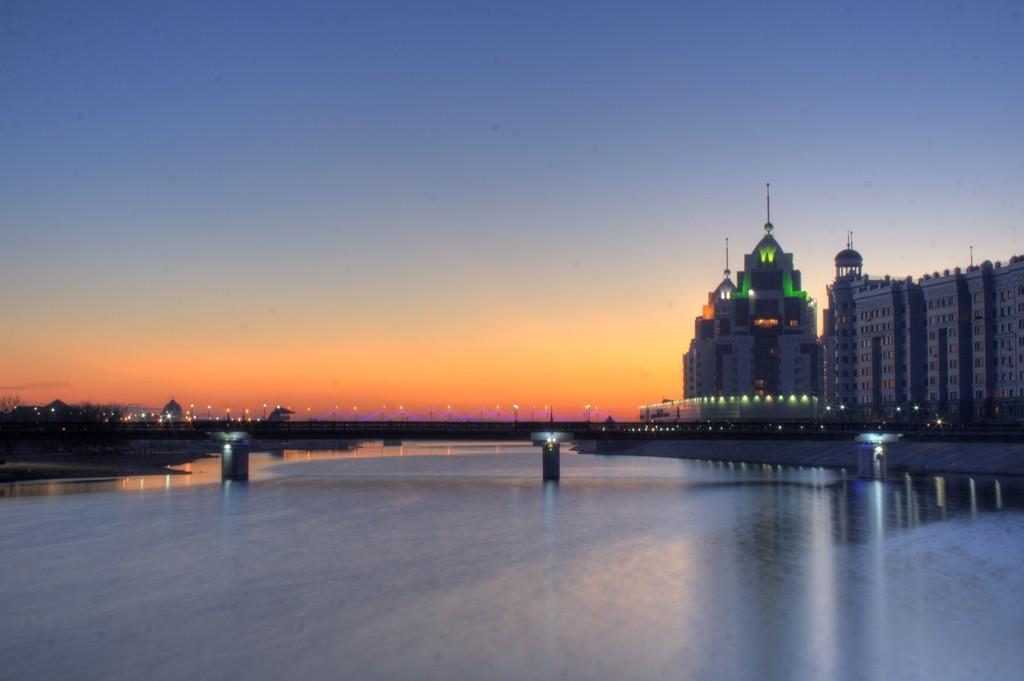Could you give a brief overview of what you see in this image? This picture is clicked outside the city. At the bottom of the picture, we see the road and pillars. We even see water on the road. On the right corner of the picture, there are many buildings. There are many street lights and trees in the background and at the top of the picture, we see the sky. 